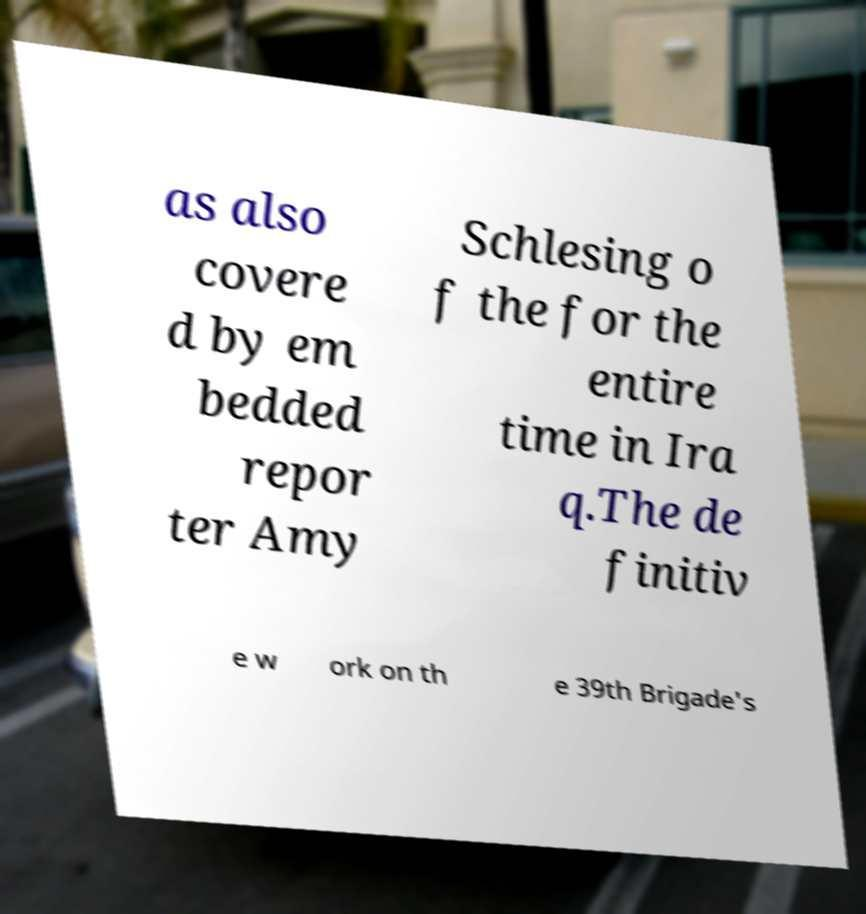For documentation purposes, I need the text within this image transcribed. Could you provide that? as also covere d by em bedded repor ter Amy Schlesing o f the for the entire time in Ira q.The de finitiv e w ork on th e 39th Brigade's 